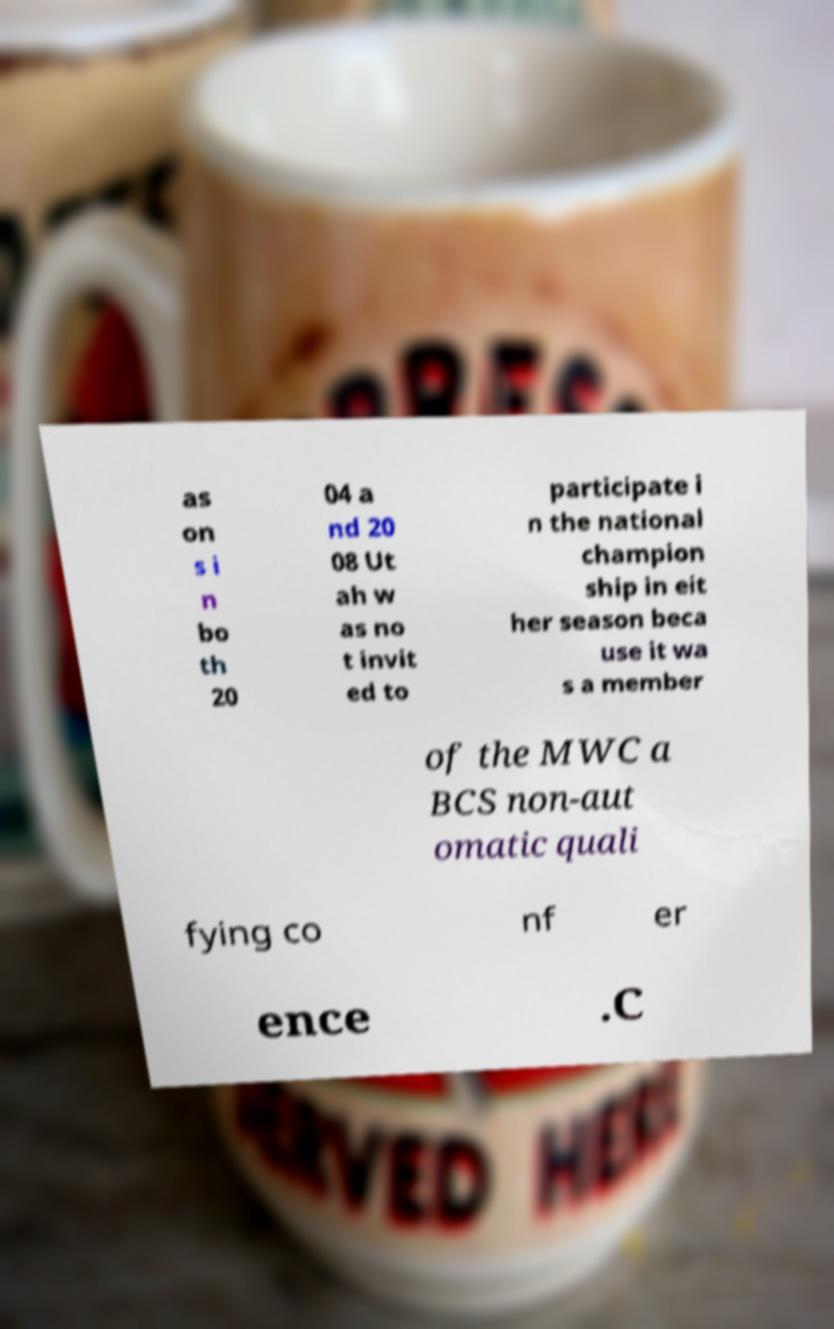Can you accurately transcribe the text from the provided image for me? as on s i n bo th 20 04 a nd 20 08 Ut ah w as no t invit ed to participate i n the national champion ship in eit her season beca use it wa s a member of the MWC a BCS non-aut omatic quali fying co nf er ence .C 